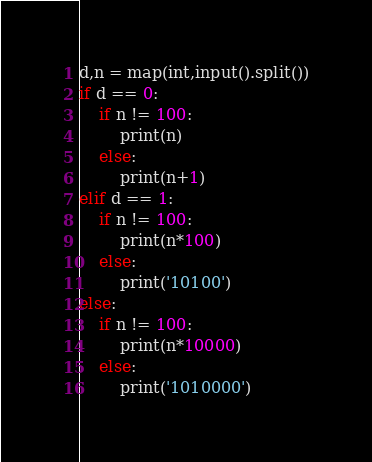<code> <loc_0><loc_0><loc_500><loc_500><_Python_>d,n = map(int,input().split())
if d == 0:
    if n != 100:
        print(n)
    else:
        print(n+1)
elif d == 1:
    if n != 100:
        print(n*100)
    else:
        print('10100')
else:
    if n != 100:
        print(n*10000)
    else:
        print('1010000')</code> 